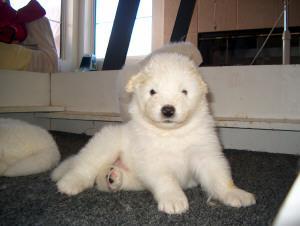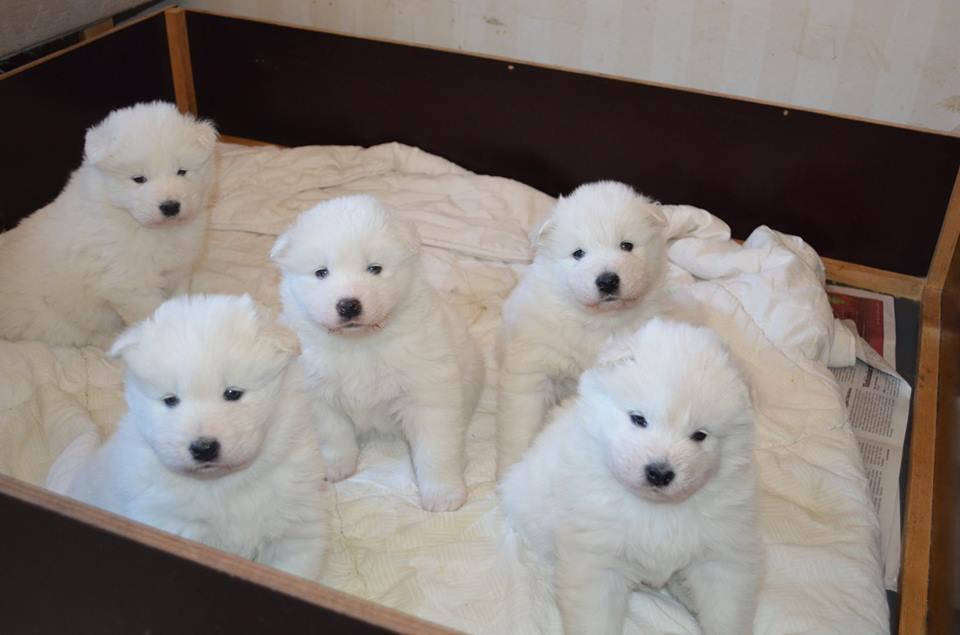The first image is the image on the left, the second image is the image on the right. Given the left and right images, does the statement "one of the pictures has a human arm in it" hold true? Answer yes or no. No. 